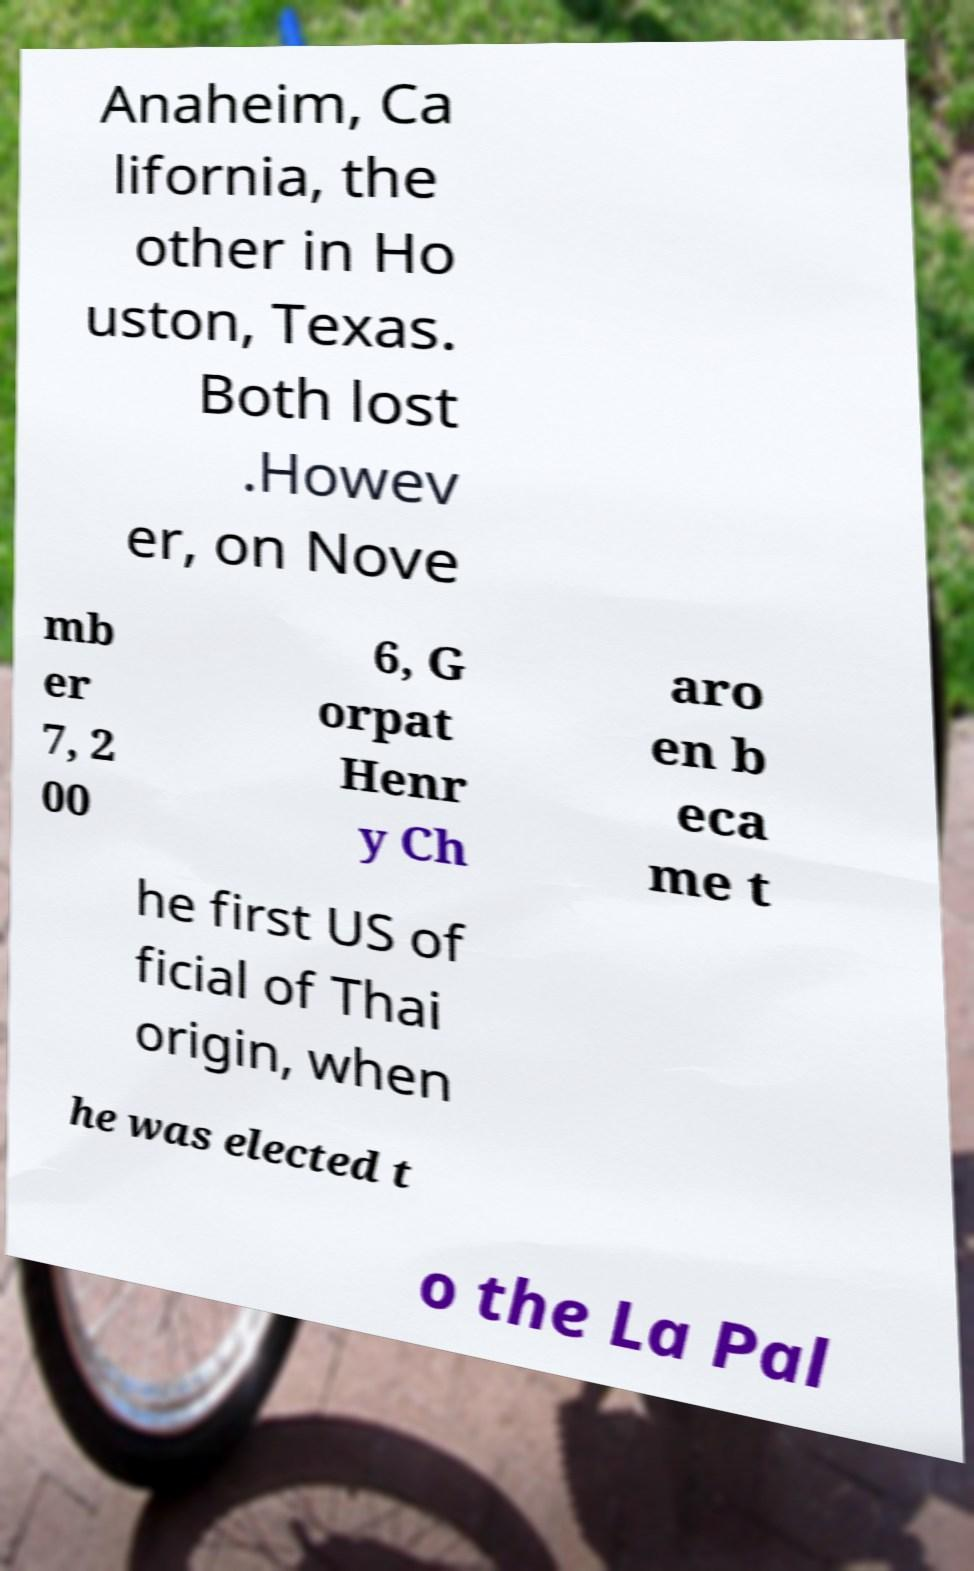There's text embedded in this image that I need extracted. Can you transcribe it verbatim? Anaheim, Ca lifornia, the other in Ho uston, Texas. Both lost .Howev er, on Nove mb er 7, 2 00 6, G orpat Henr y Ch aro en b eca me t he first US of ficial of Thai origin, when he was elected t o the La Pal 